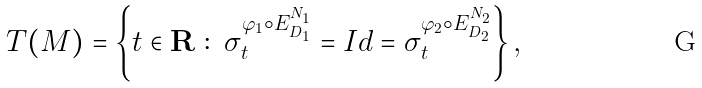Convert formula to latex. <formula><loc_0><loc_0><loc_500><loc_500>T ( M ) = \left \{ t \in { \mathbf R } \ \colon \ \sigma _ { t } ^ { \varphi _ { 1 } \circ E _ { D _ { 1 } } ^ { N _ { 1 } } } = I d = \sigma _ { t } ^ { \varphi _ { 2 } \circ E _ { D _ { 2 } } ^ { N _ { 2 } } } \right \} ,</formula> 